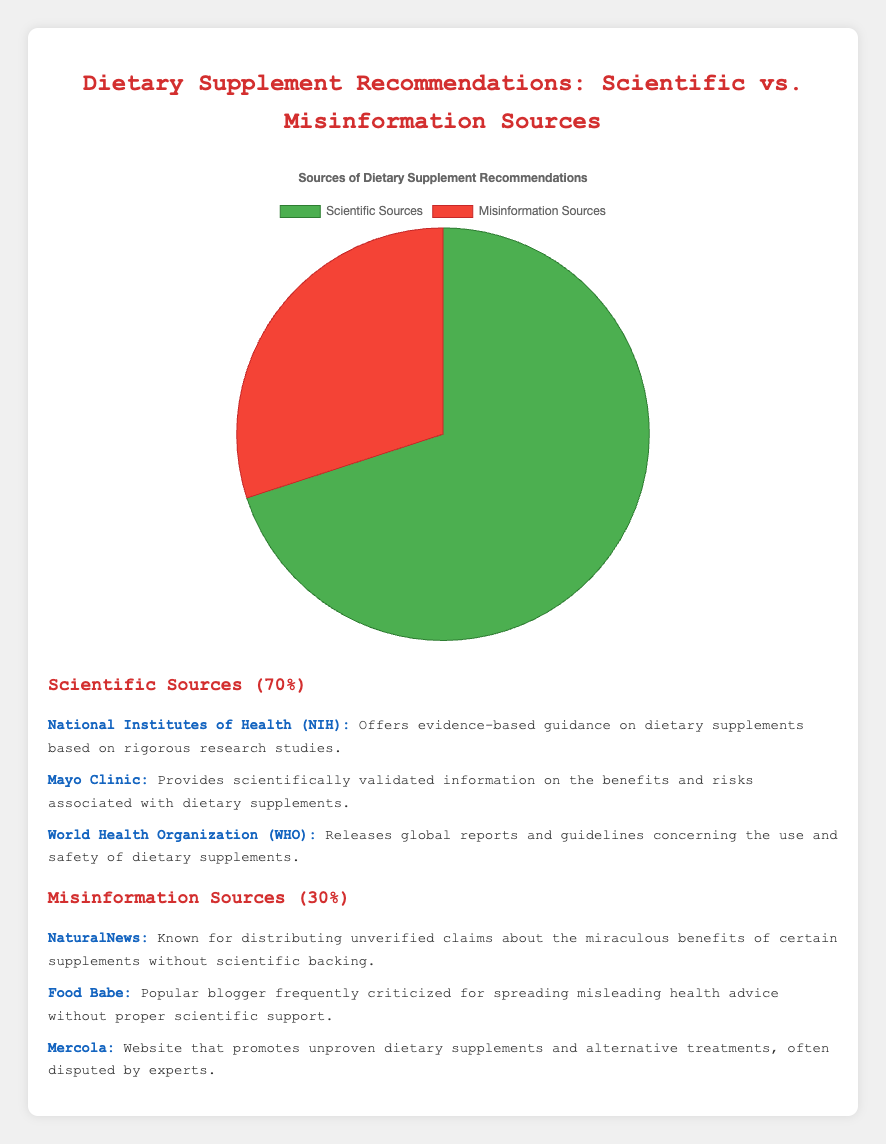What percentage of dietary supplement recommendations come from scientific sources? According to the pie chart, 70% of dietary supplement recommendations come from scientific sources.
Answer: 70% What are some examples of misinformation sources mentioned in the figure? The figure lists NaturalNews, Food Babe, and Mercola as examples of misinformation sources.
Answer: NaturalNews, Food Babe, Mercola What is the combined percentage of recommendations from scientific sources and misinformation sources? To find the combined percentage, add the percentages of both sources: 70% (scientific sources) + 30% (misinformation sources) = 100%.
Answer: 100% Which color represents the scientific sources in the pie chart? The pie chart uses green to represent scientific sources.
Answer: Green Which source type, scientific or misinformation, is more prevalent in dietary supplement recommendations? By comparing percentages, the scientific sources (70%) are more prevalent than misinformation sources (30%).
Answer: Scientific sources What is the difference in percentage between the scientific and misinformation sources? The difference in percentage can be calculated by subtracting the misinformation sources percentage from the scientific sources percentage: 70% - 30% = 40%.
Answer: 40% List the scientific sources mentioned in the figure. The figure mentions National Institutes of Health (NIH), Mayo Clinic, and World Health Organization (WHO) as scientific sources.
Answer: National Institutes of Health (NIH), Mayo Clinic, World Health Organization (WHO) What visual attribute is used to distinguish the scientific sources from the misinformation sources? The pie chart uses color to distinguish between the sources, with scientific sources represented in green and misinformation sources represented in red.
Answer: Color (green for scientific, red for misinformation) If a new source is added to the scientific category, making it account for 72% of the recommendations, what would the new percentage of misinformation sources be? If scientific sources increase to 72%, the new percentage for misinformation sources would be 100% - 72% = 28%.
Answer: 28% 